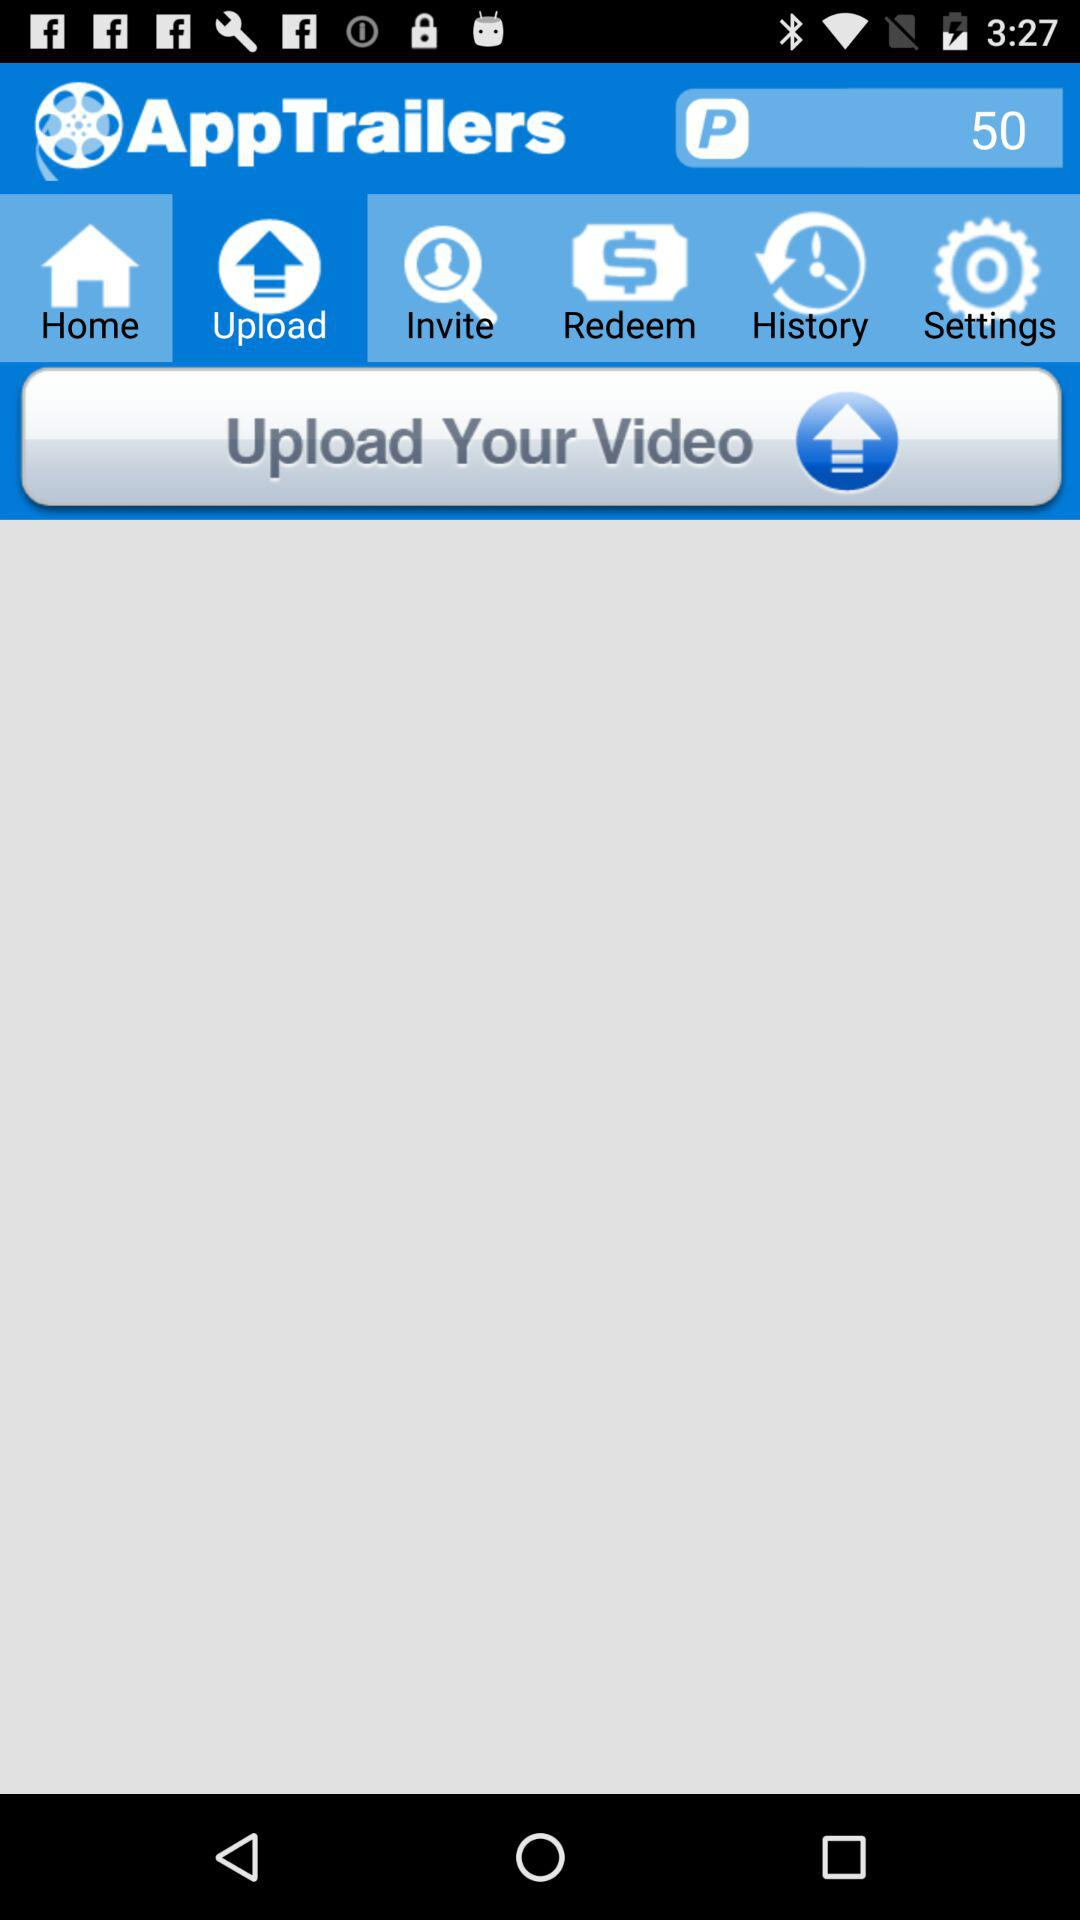What is the name of the application? The name of the application is "AppTrailers". 